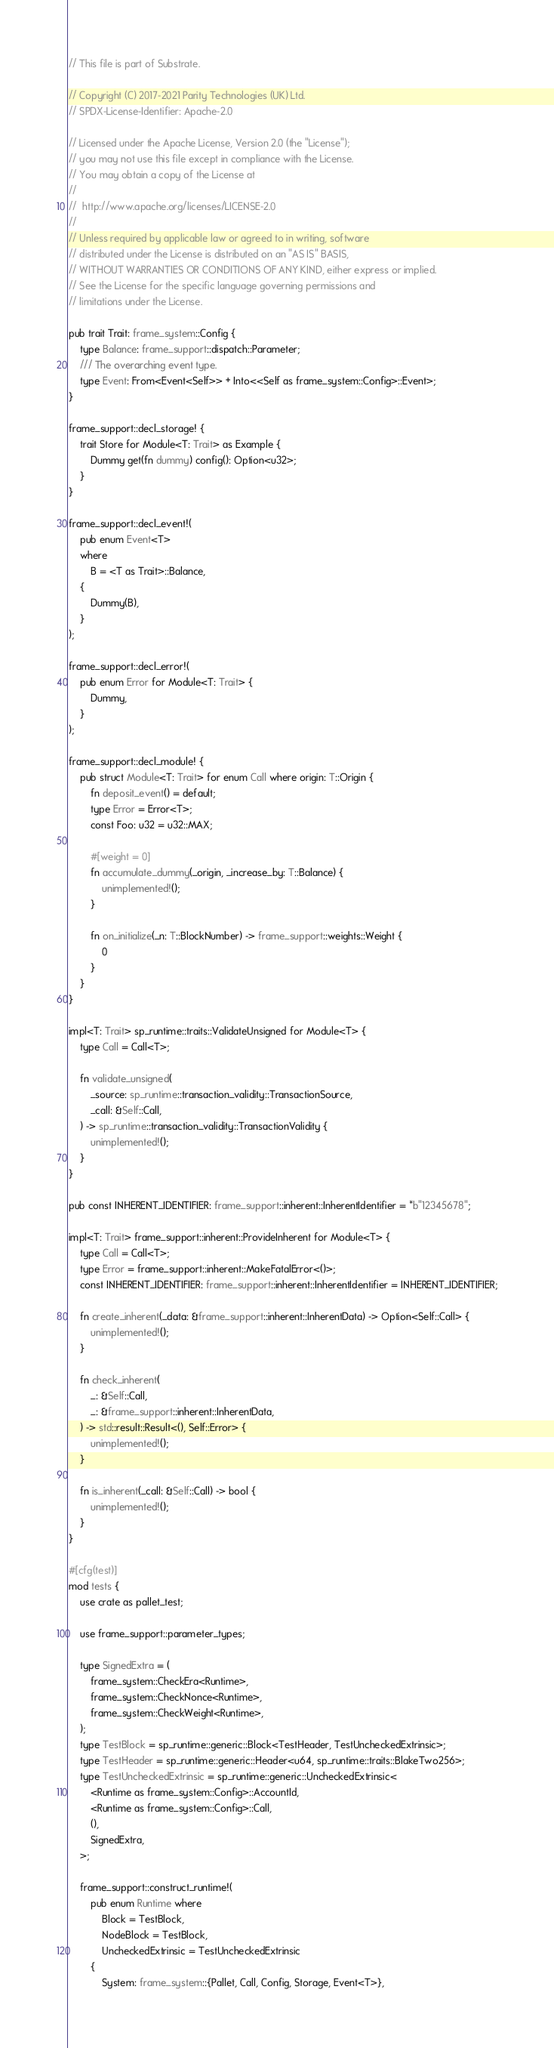Convert code to text. <code><loc_0><loc_0><loc_500><loc_500><_Rust_>// This file is part of Substrate.

// Copyright (C) 2017-2021 Parity Technologies (UK) Ltd.
// SPDX-License-Identifier: Apache-2.0

// Licensed under the Apache License, Version 2.0 (the "License");
// you may not use this file except in compliance with the License.
// You may obtain a copy of the License at
//
// 	http://www.apache.org/licenses/LICENSE-2.0
//
// Unless required by applicable law or agreed to in writing, software
// distributed under the License is distributed on an "AS IS" BASIS,
// WITHOUT WARRANTIES OR CONDITIONS OF ANY KIND, either express or implied.
// See the License for the specific language governing permissions and
// limitations under the License.

pub trait Trait: frame_system::Config {
	type Balance: frame_support::dispatch::Parameter;
	/// The overarching event type.
	type Event: From<Event<Self>> + Into<<Self as frame_system::Config>::Event>;
}

frame_support::decl_storage! {
	trait Store for Module<T: Trait> as Example {
		Dummy get(fn dummy) config(): Option<u32>;
	}
}

frame_support::decl_event!(
	pub enum Event<T>
	where
		B = <T as Trait>::Balance,
	{
		Dummy(B),
	}
);

frame_support::decl_error!(
	pub enum Error for Module<T: Trait> {
		Dummy,
	}
);

frame_support::decl_module! {
	pub struct Module<T: Trait> for enum Call where origin: T::Origin {
		fn deposit_event() = default;
		type Error = Error<T>;
		const Foo: u32 = u32::MAX;

		#[weight = 0]
		fn accumulate_dummy(_origin, _increase_by: T::Balance) {
			unimplemented!();
		}

		fn on_initialize(_n: T::BlockNumber) -> frame_support::weights::Weight {
			0
		}
	}
}

impl<T: Trait> sp_runtime::traits::ValidateUnsigned for Module<T> {
	type Call = Call<T>;

	fn validate_unsigned(
		_source: sp_runtime::transaction_validity::TransactionSource,
		_call: &Self::Call,
	) -> sp_runtime::transaction_validity::TransactionValidity {
		unimplemented!();
	}
}

pub const INHERENT_IDENTIFIER: frame_support::inherent::InherentIdentifier = *b"12345678";

impl<T: Trait> frame_support::inherent::ProvideInherent for Module<T> {
	type Call = Call<T>;
	type Error = frame_support::inherent::MakeFatalError<()>;
	const INHERENT_IDENTIFIER: frame_support::inherent::InherentIdentifier = INHERENT_IDENTIFIER;

	fn create_inherent(_data: &frame_support::inherent::InherentData) -> Option<Self::Call> {
		unimplemented!();
	}

	fn check_inherent(
		_: &Self::Call,
		_: &frame_support::inherent::InherentData,
	) -> std::result::Result<(), Self::Error> {
		unimplemented!();
	}

	fn is_inherent(_call: &Self::Call) -> bool {
		unimplemented!();
	}
}

#[cfg(test)]
mod tests {
	use crate as pallet_test;

	use frame_support::parameter_types;

	type SignedExtra = (
		frame_system::CheckEra<Runtime>,
		frame_system::CheckNonce<Runtime>,
		frame_system::CheckWeight<Runtime>,
	);
	type TestBlock = sp_runtime::generic::Block<TestHeader, TestUncheckedExtrinsic>;
	type TestHeader = sp_runtime::generic::Header<u64, sp_runtime::traits::BlakeTwo256>;
	type TestUncheckedExtrinsic = sp_runtime::generic::UncheckedExtrinsic<
		<Runtime as frame_system::Config>::AccountId,
		<Runtime as frame_system::Config>::Call,
		(),
		SignedExtra,
	>;

	frame_support::construct_runtime!(
		pub enum Runtime where
			Block = TestBlock,
			NodeBlock = TestBlock,
			UncheckedExtrinsic = TestUncheckedExtrinsic
		{
			System: frame_system::{Pallet, Call, Config, Storage, Event<T>},</code> 